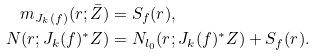Convert formula to latex. <formula><loc_0><loc_0><loc_500><loc_500>m _ { J _ { k } ( f ) } ( r ; \bar { Z } ) & = S _ { f } ( r ) , \\ N ( r ; J _ { k } ( f ) ^ { * } Z ) & = N _ { l _ { 0 } } ( r ; J _ { k } ( f ) ^ { * } Z ) + S _ { f } ( r ) .</formula> 